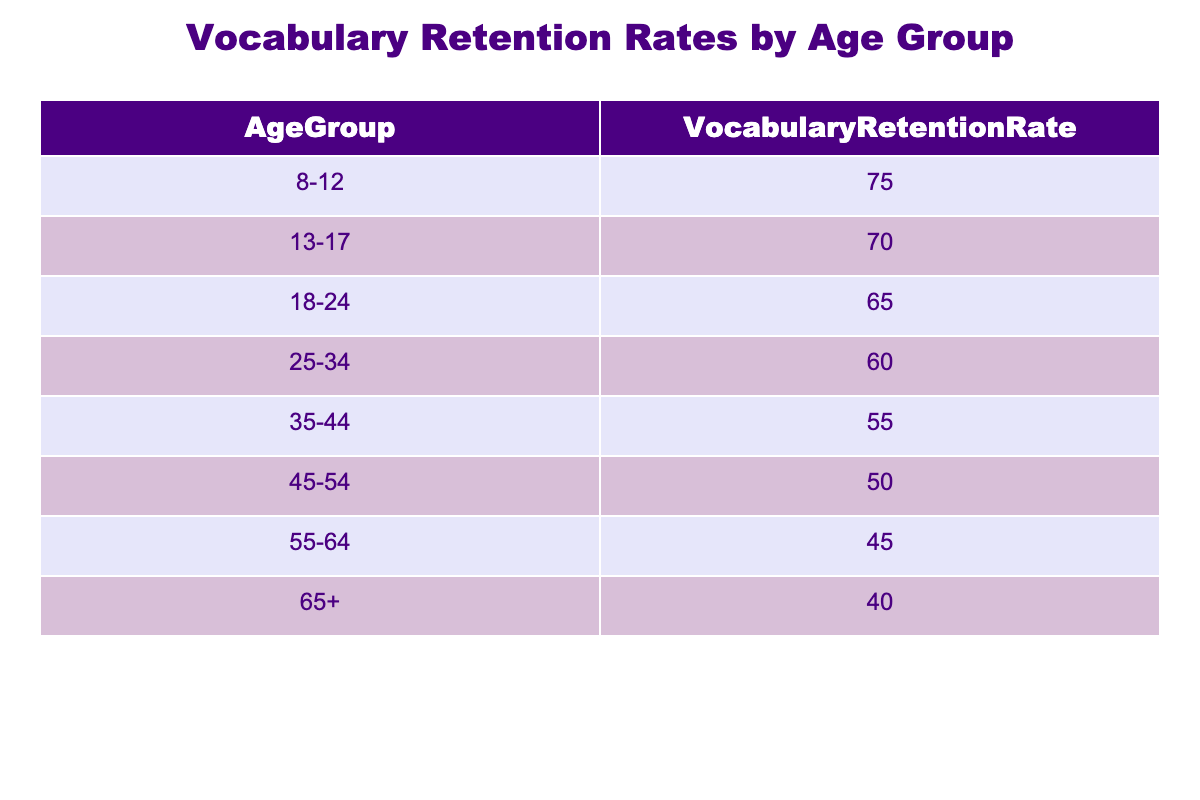What is the vocabulary retention rate for the age group 35-44? The table lists the vocabulary retention rate for each age group. We look at the row for the age group 35-44, where the retention rate is mentioned as 55.
Answer: 55 Which age group has the highest vocabulary retention rate? By examining the table, we see that the age group 8-12 has a retention rate of 75, which is the highest among all age groups listed.
Answer: 8-12 What is the difference in vocabulary retention rates between the age groups 25-34 and 45-54? The retention rate for 25-34 is 60, and for 45-54 it is 50. To find the difference, we subtract 50 from 60, resulting in a difference of 10.
Answer: 10 Is it true that the vocabulary retention rate decreases for every subsequent age group? We can check the values in the table by comparing each successive age group's retention rate. The rates decrease as we move from 8-12 (75) down to 65+ (40), confirming that it is true.
Answer: Yes What is the average vocabulary retention rate for learners aged 18 and above? We need to consider the age groups 18-24, 25-34, 35-44, 45-54, 55-64, and 65+. Their rates are 65, 60, 55, 50, 45, and 40 respectively. The sum of these rates is 315, and there are 6 age groups, so we divide 315 by 6, giving an average of 52.5.
Answer: 52.5 Which age group has a vocabulary retention rate that is closest to the overall average of all groups? First, we need to find the overall average of all groups. Adding all retention rates (75 + 70 + 65 + 60 + 55 + 50 + 45 + 40 = 450) and dividing by 8 gives us an average of 56.25. Comparing this to the retention rates, the closest value is 55 from the age group 35-44.
Answer: 35-44 What can we infer about vocabulary retention rates for learners over the age of 34? In the table, the retention rates for the age groups over 34 (35-44, 45-54, 55-64, 65+) are 55, 50, 45, and 40 respectively. This indicates a consistent decline in retention rates as age increases, suggesting older learners retain vocabulary less effectively.
Answer: They decline consistently What is the sum of the vocabulary retention rates for the age groups 13-17 and 18-24? The retention rates for 13-17 and 18-24 are 70 and 65, respectively. To find the sum, we add these two values: 70 + 65 = 135.
Answer: 135 